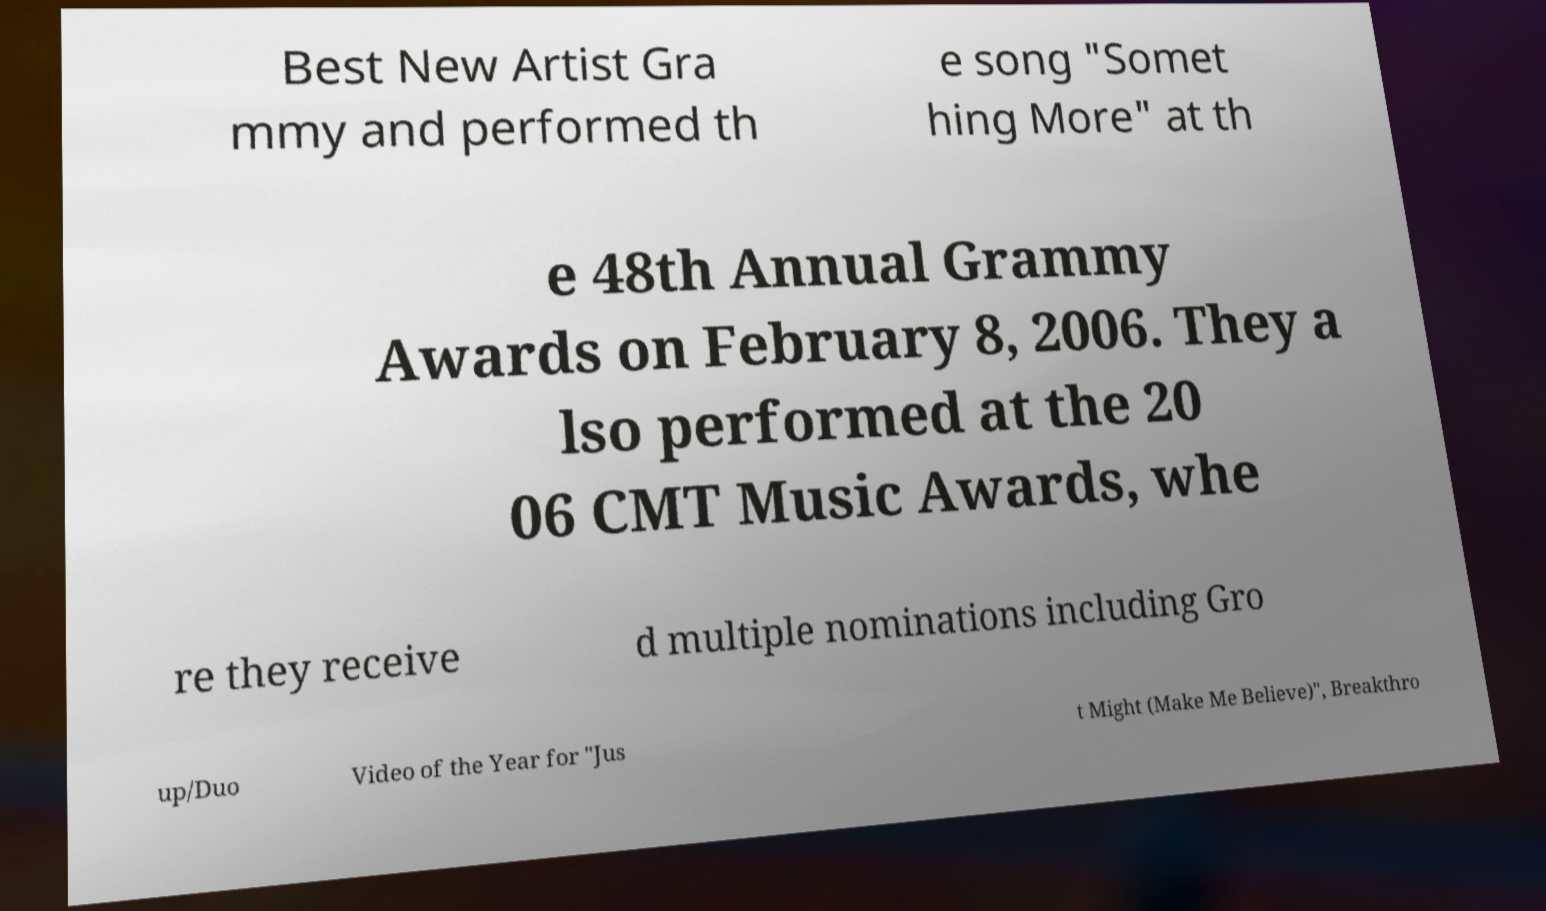Please read and relay the text visible in this image. What does it say? Best New Artist Gra mmy and performed th e song "Somet hing More" at th e 48th Annual Grammy Awards on February 8, 2006. They a lso performed at the 20 06 CMT Music Awards, whe re they receive d multiple nominations including Gro up/Duo Video of the Year for "Jus t Might (Make Me Believe)", Breakthro 